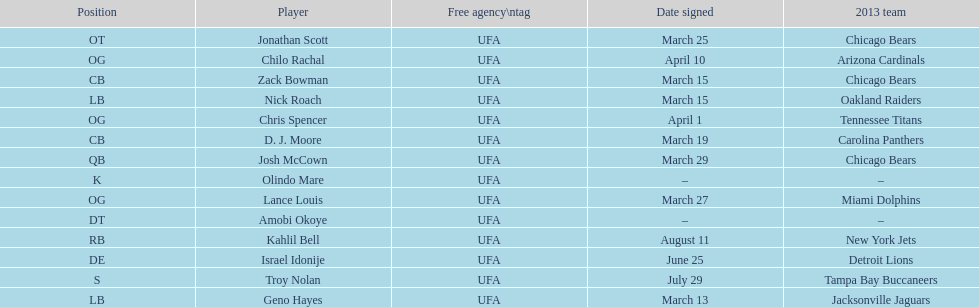On the same day as nick roach, which other player was signed? Zack Bowman. 